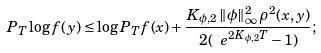Convert formula to latex. <formula><loc_0><loc_0><loc_500><loc_500>P _ { T } \log f ( y ) \leq \log P _ { T } f ( x ) + \frac { K _ { \phi , 2 } \, \| \phi \| ^ { 2 } _ { \infty } \, \rho ^ { 2 } ( x , y ) } { 2 ( \ e ^ { 2 K _ { \phi , 2 } T } - 1 ) } ;</formula> 